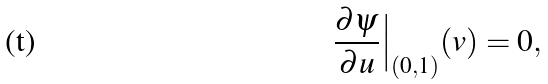<formula> <loc_0><loc_0><loc_500><loc_500>\frac { \partial \psi } { \partial u } \Big | _ { ( 0 , 1 ) } ( v ) = 0 ,</formula> 